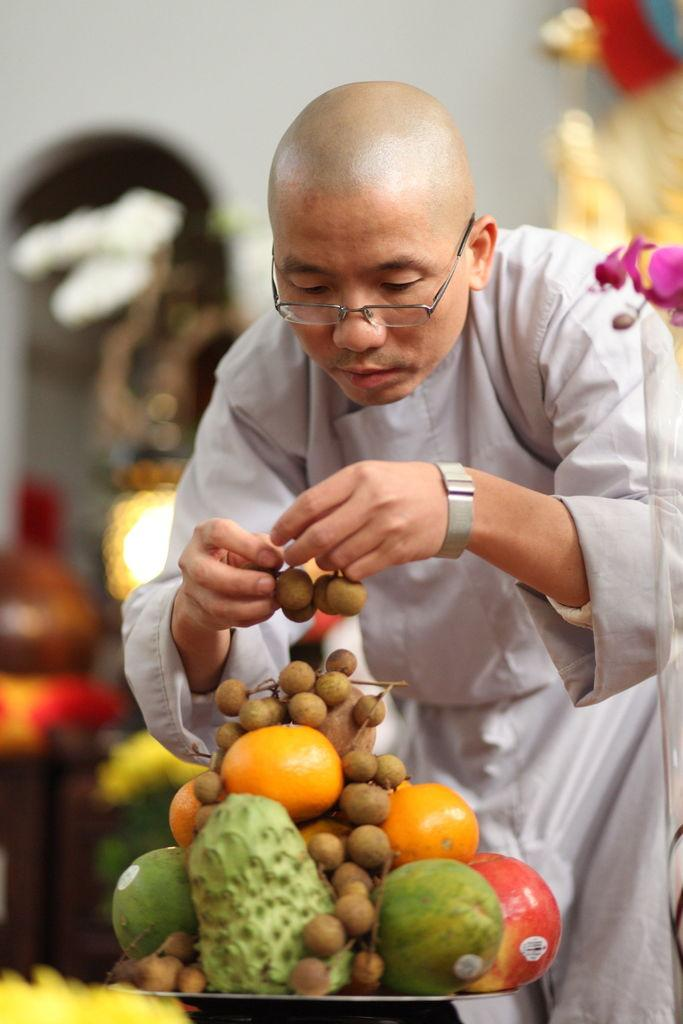What is on the plate that is visible in the image? The plate contains fruits in the image. Who is present in the image besides the plate? There is a man standing behind the plate in the image. What is the man holding in his hand? The man is holding fruits in his hand. Can you describe the background of the image? The background of the image is blurred. Is there any smoke coming from the plate in the image? No, there is no smoke present in the image. 